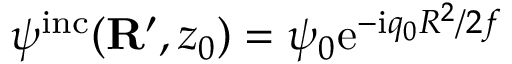Convert formula to latex. <formula><loc_0><loc_0><loc_500><loc_500>\psi ^ { i n c } ( { R } ^ { \prime } , z _ { 0 } ) = \psi _ { 0 } e ^ { - i q _ { 0 } R ^ { 2 } / 2 f }</formula> 